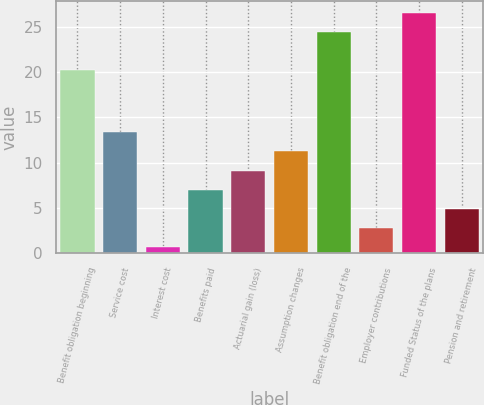Convert chart. <chart><loc_0><loc_0><loc_500><loc_500><bar_chart><fcel>Benefit obligation beginning<fcel>Service cost<fcel>Interest cost<fcel>Benefits paid<fcel>Actuarial gain (loss)<fcel>Assumption changes<fcel>Benefit obligation end of the<fcel>Employer contributions<fcel>Funded Status of the plans<fcel>Pension and retirement<nl><fcel>20.2<fcel>13.36<fcel>0.7<fcel>7.03<fcel>9.14<fcel>11.25<fcel>24.42<fcel>2.81<fcel>26.53<fcel>4.92<nl></chart> 